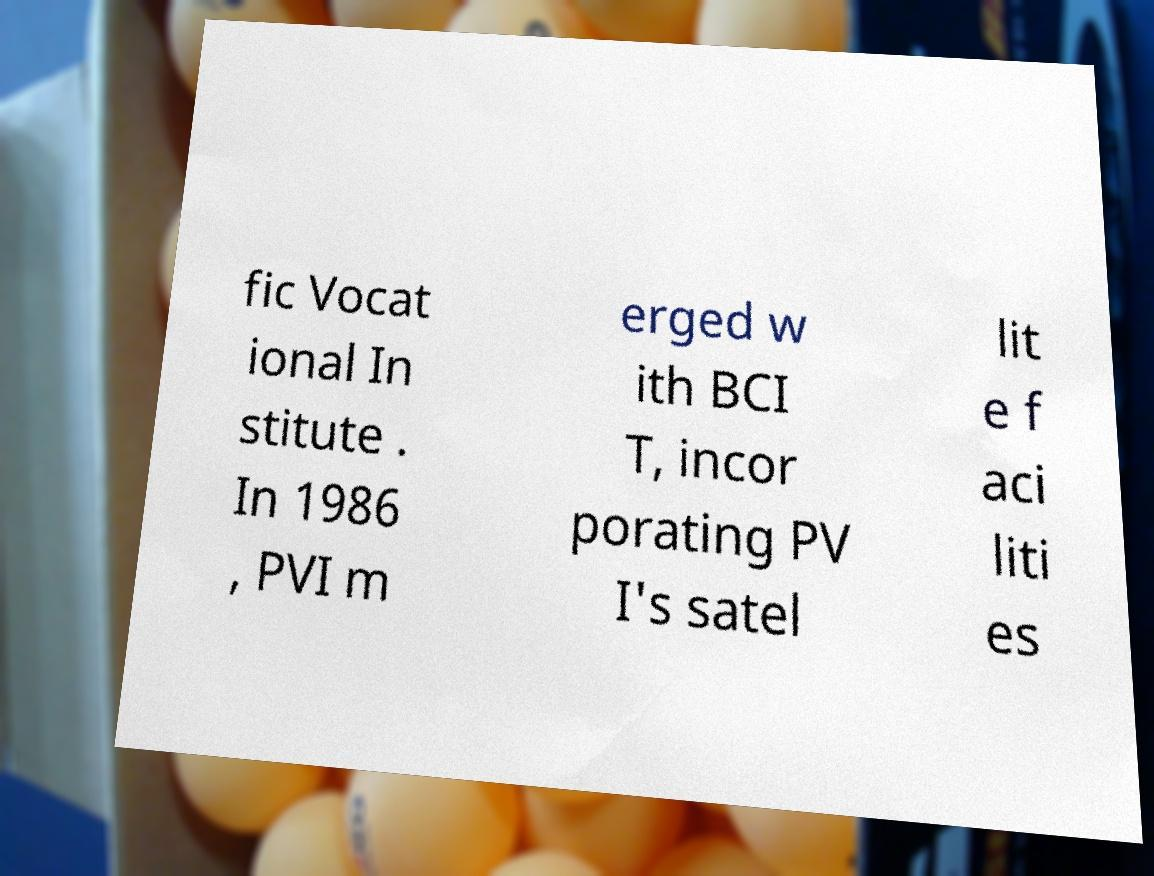There's text embedded in this image that I need extracted. Can you transcribe it verbatim? fic Vocat ional In stitute . In 1986 , PVI m erged w ith BCI T, incor porating PV I's satel lit e f aci liti es 